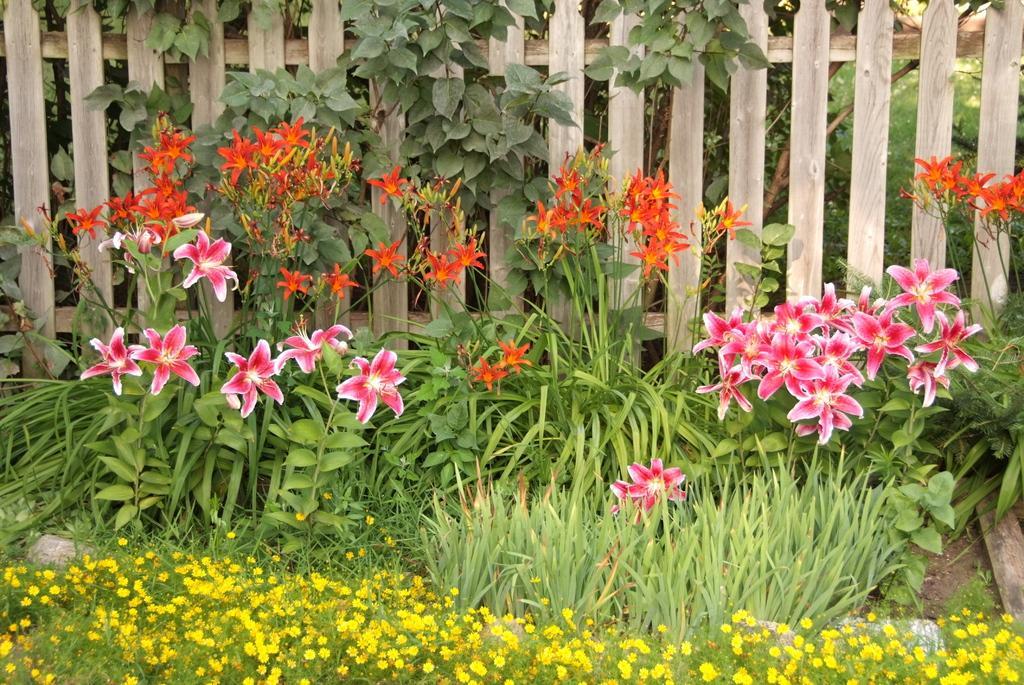Can you describe this image briefly? In this image I can see the flowers to the plants. These flowers are in pink, white, orange and yellow color. To the side I can see the wooden fence. 